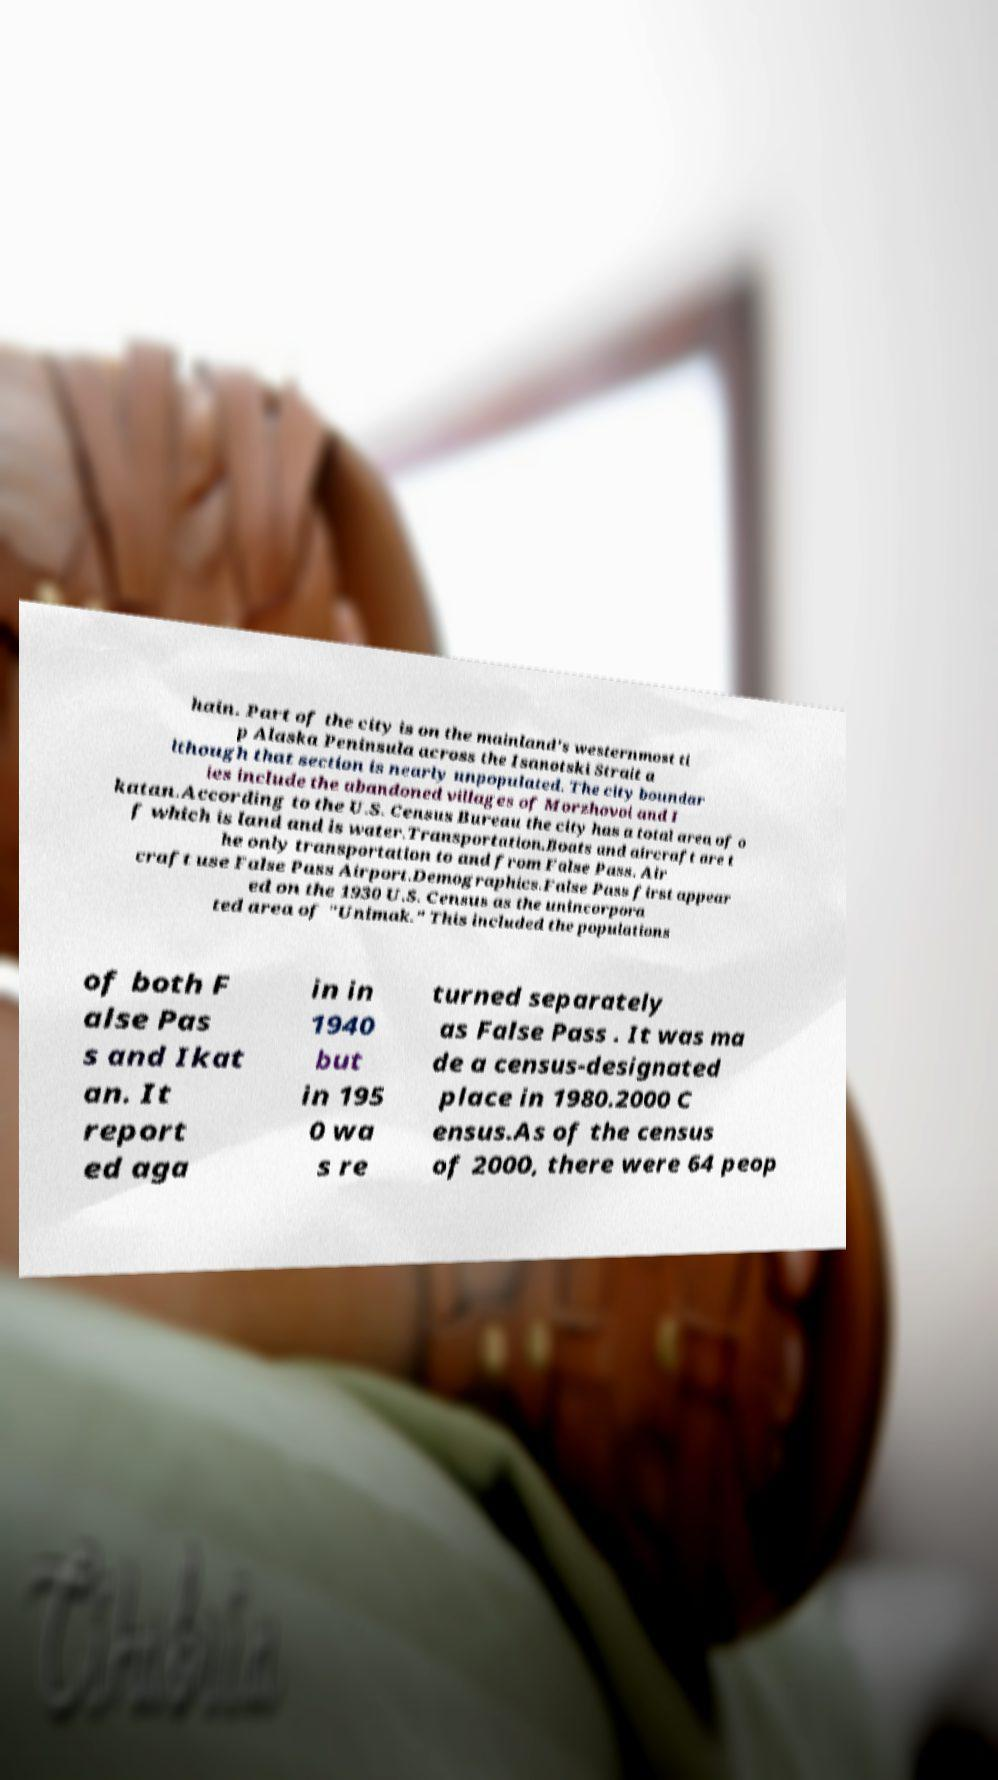There's text embedded in this image that I need extracted. Can you transcribe it verbatim? hain. Part of the city is on the mainland's westernmost ti p Alaska Peninsula across the Isanotski Strait a lthough that section is nearly unpopulated. The city boundar ies include the abandoned villages of Morzhovoi and I katan.According to the U.S. Census Bureau the city has a total area of o f which is land and is water.Transportation.Boats and aircraft are t he only transportation to and from False Pass. Air craft use False Pass Airport.Demographics.False Pass first appear ed on the 1930 U.S. Census as the unincorpora ted area of "Unimak." This included the populations of both F alse Pas s and Ikat an. It report ed aga in in 1940 but in 195 0 wa s re turned separately as False Pass . It was ma de a census-designated place in 1980.2000 C ensus.As of the census of 2000, there were 64 peop 